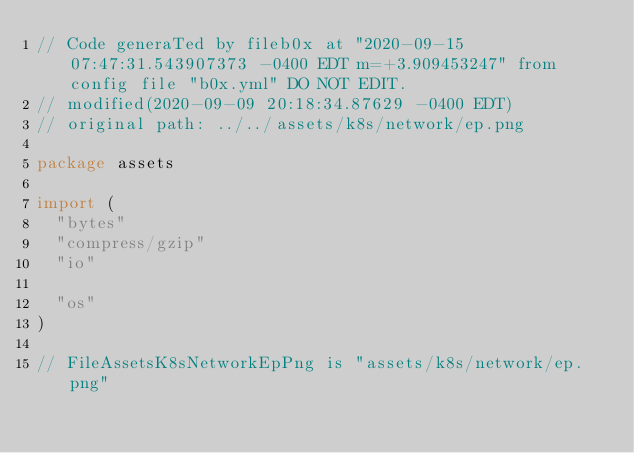Convert code to text. <code><loc_0><loc_0><loc_500><loc_500><_Go_>// Code generaTed by fileb0x at "2020-09-15 07:47:31.543907373 -0400 EDT m=+3.909453247" from config file "b0x.yml" DO NOT EDIT.
// modified(2020-09-09 20:18:34.87629 -0400 EDT)
// original path: ../../assets/k8s/network/ep.png

package assets

import (
	"bytes"
	"compress/gzip"
	"io"

	"os"
)

// FileAssetsK8sNetworkEpPng is "assets/k8s/network/ep.png"</code> 